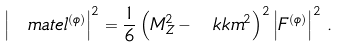<formula> <loc_0><loc_0><loc_500><loc_500>\left | \ m a t e l ^ { ( \phi ) } \right | ^ { 2 } = \frac { 1 } { 6 } \left ( M _ { Z } ^ { 2 } - \ k k m ^ { 2 } \right ) ^ { 2 } \left | F ^ { ( \phi ) } \right | ^ { 2 } \, .</formula> 